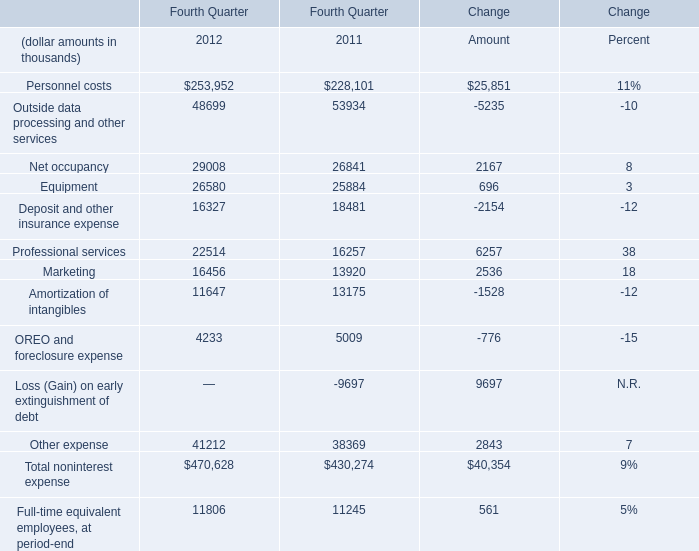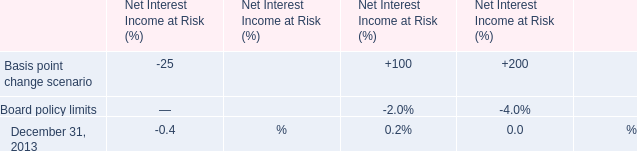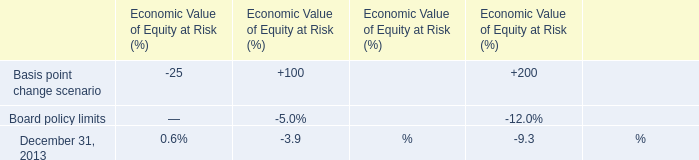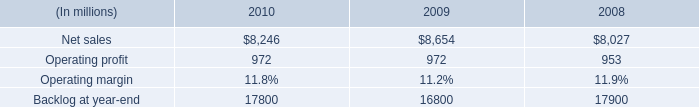What is the total amount of Net sales of 2009, and Other expense of Change Amount ? 
Computations: (8654.0 + 2843.0)
Answer: 11497.0. 